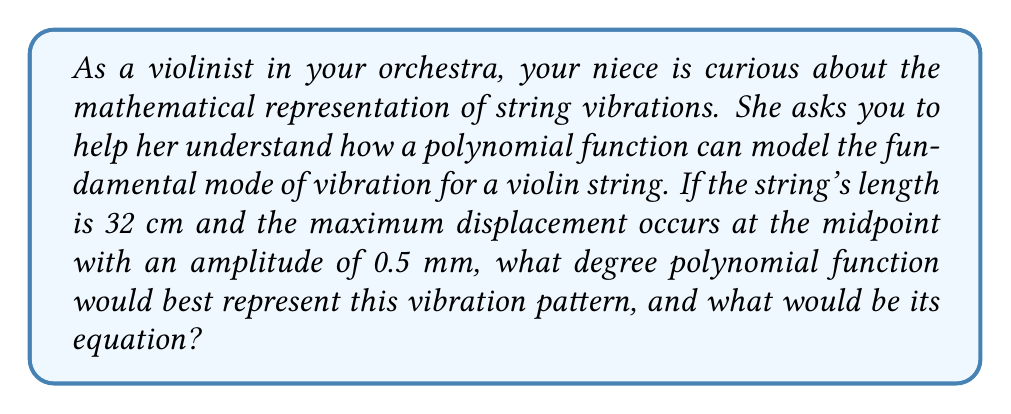Teach me how to tackle this problem. To model the fundamental mode of vibration for a violin string, we can use a polynomial function. Let's approach this step-by-step:

1) The fundamental mode of vibration for a string fixed at both ends resembles a half-sine wave. This shape can be closely approximated by a quadratic function.

2) We'll use a coordinate system where:
   - The x-axis represents the length of the string (0 to 32 cm)
   - The y-axis represents the displacement of the string (in mm)

3) We know three key points for this function:
   - At x = 0, y = 0 (string fixed at one end)
   - At x = 16, y = 0.5 (maximum displacement at midpoint)
   - At x = 32, y = 0 (string fixed at other end)

4) The general form of a quadratic function is:

   $$y = ax^2 + bx + c$$

5) Given the symmetry of the vibration, the vertex of the parabola should be at x = 16. We can use the vertex form of a quadratic equation:

   $$y = a(x - h)^2 + k$$

   Where (h, k) is the vertex, in this case (16, 0.5)

6) Substituting these values:

   $$y = a(x - 16)^2 + 0.5$$

7) We can find 'a' using the point (0, 0):

   $$0 = a(0 - 16)^2 + 0.5$$
   $$-0.5 = a(256)$$
   $$a = -\frac{0.5}{256} = -\frac{1}{512}$$

8) Therefore, the equation that models the string's vibration is:

   $$y = -\frac{1}{512}(x - 16)^2 + 0.5$$

This quadratic (degree 2) polynomial function accurately represents the fundamental mode of vibration for the violin string under the given conditions.
Answer: The best polynomial function to represent this vibration pattern is a quadratic (degree 2) function. Its equation is:

$$y = -\frac{1}{512}(x - 16)^2 + 0.5$$

where x is the position along the string in cm, and y is the displacement in mm. 